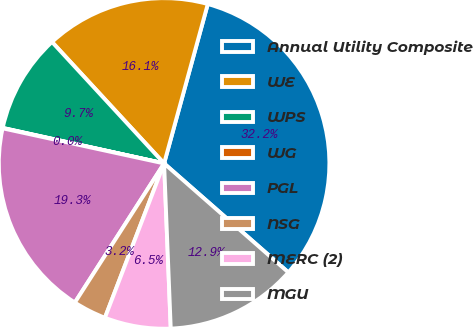Convert chart to OTSL. <chart><loc_0><loc_0><loc_500><loc_500><pie_chart><fcel>Annual Utility Composite<fcel>WE<fcel>WPS<fcel>WG<fcel>PGL<fcel>NSG<fcel>MERC (2)<fcel>MGU<nl><fcel>32.2%<fcel>16.12%<fcel>9.69%<fcel>0.04%<fcel>19.33%<fcel>3.25%<fcel>6.47%<fcel>12.9%<nl></chart> 